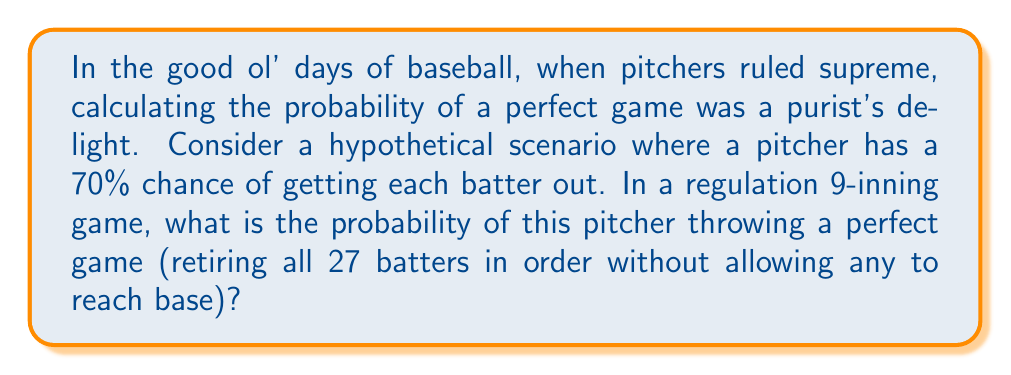Can you answer this question? Let's approach this step-by-step, keeping in mind the traditional beauty of the game:

1) In a perfect game, the pitcher must retire all 27 batters in order. This means we need 27 consecutive successful outcomes.

2) The probability of getting each batter out is given as 70% or 0.7.

3) For independent events, which we'll assume each at-bat is, we multiply the probabilities of each event occurring.

4) Therefore, the probability of a perfect game is:

   $$P(\text{perfect game}) = (0.7)^{27}$$

5) Let's calculate this:
   
   $$\begin{align*}
   P(\text{perfect game}) &= (0.7)^{27} \\
   &= 0.7 \times 0.7 \times ... \times 0.7 \text{ (27 times)} \\
   &\approx 0.0000000476
   \end{align*}$$

6) To express this as a percentage:

   $$0.0000000476 \times 100\% \approx 0.00000476\%$$

This incredibly low probability showcases why perfect games are such rare and celebrated events in baseball history, occurring only 23 times in over 150 years of Major League play.
Answer: The probability of a perfect game under these conditions is approximately $0.0000000476$ or $0.00000476\%$. 